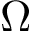Convert formula to latex. <formula><loc_0><loc_0><loc_500><loc_500>\Omega</formula> 